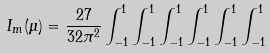Convert formula to latex. <formula><loc_0><loc_0><loc_500><loc_500>I _ { m } ( \mu ) = \frac { 2 7 } { 3 2 \pi ^ { 2 } } \int _ { - 1 } ^ { 1 } \int _ { - 1 } ^ { 1 } \int _ { - 1 } ^ { 1 } \int _ { - 1 } ^ { 1 } \int _ { - 1 } ^ { 1 } \int _ { - 1 } ^ { 1 }</formula> 